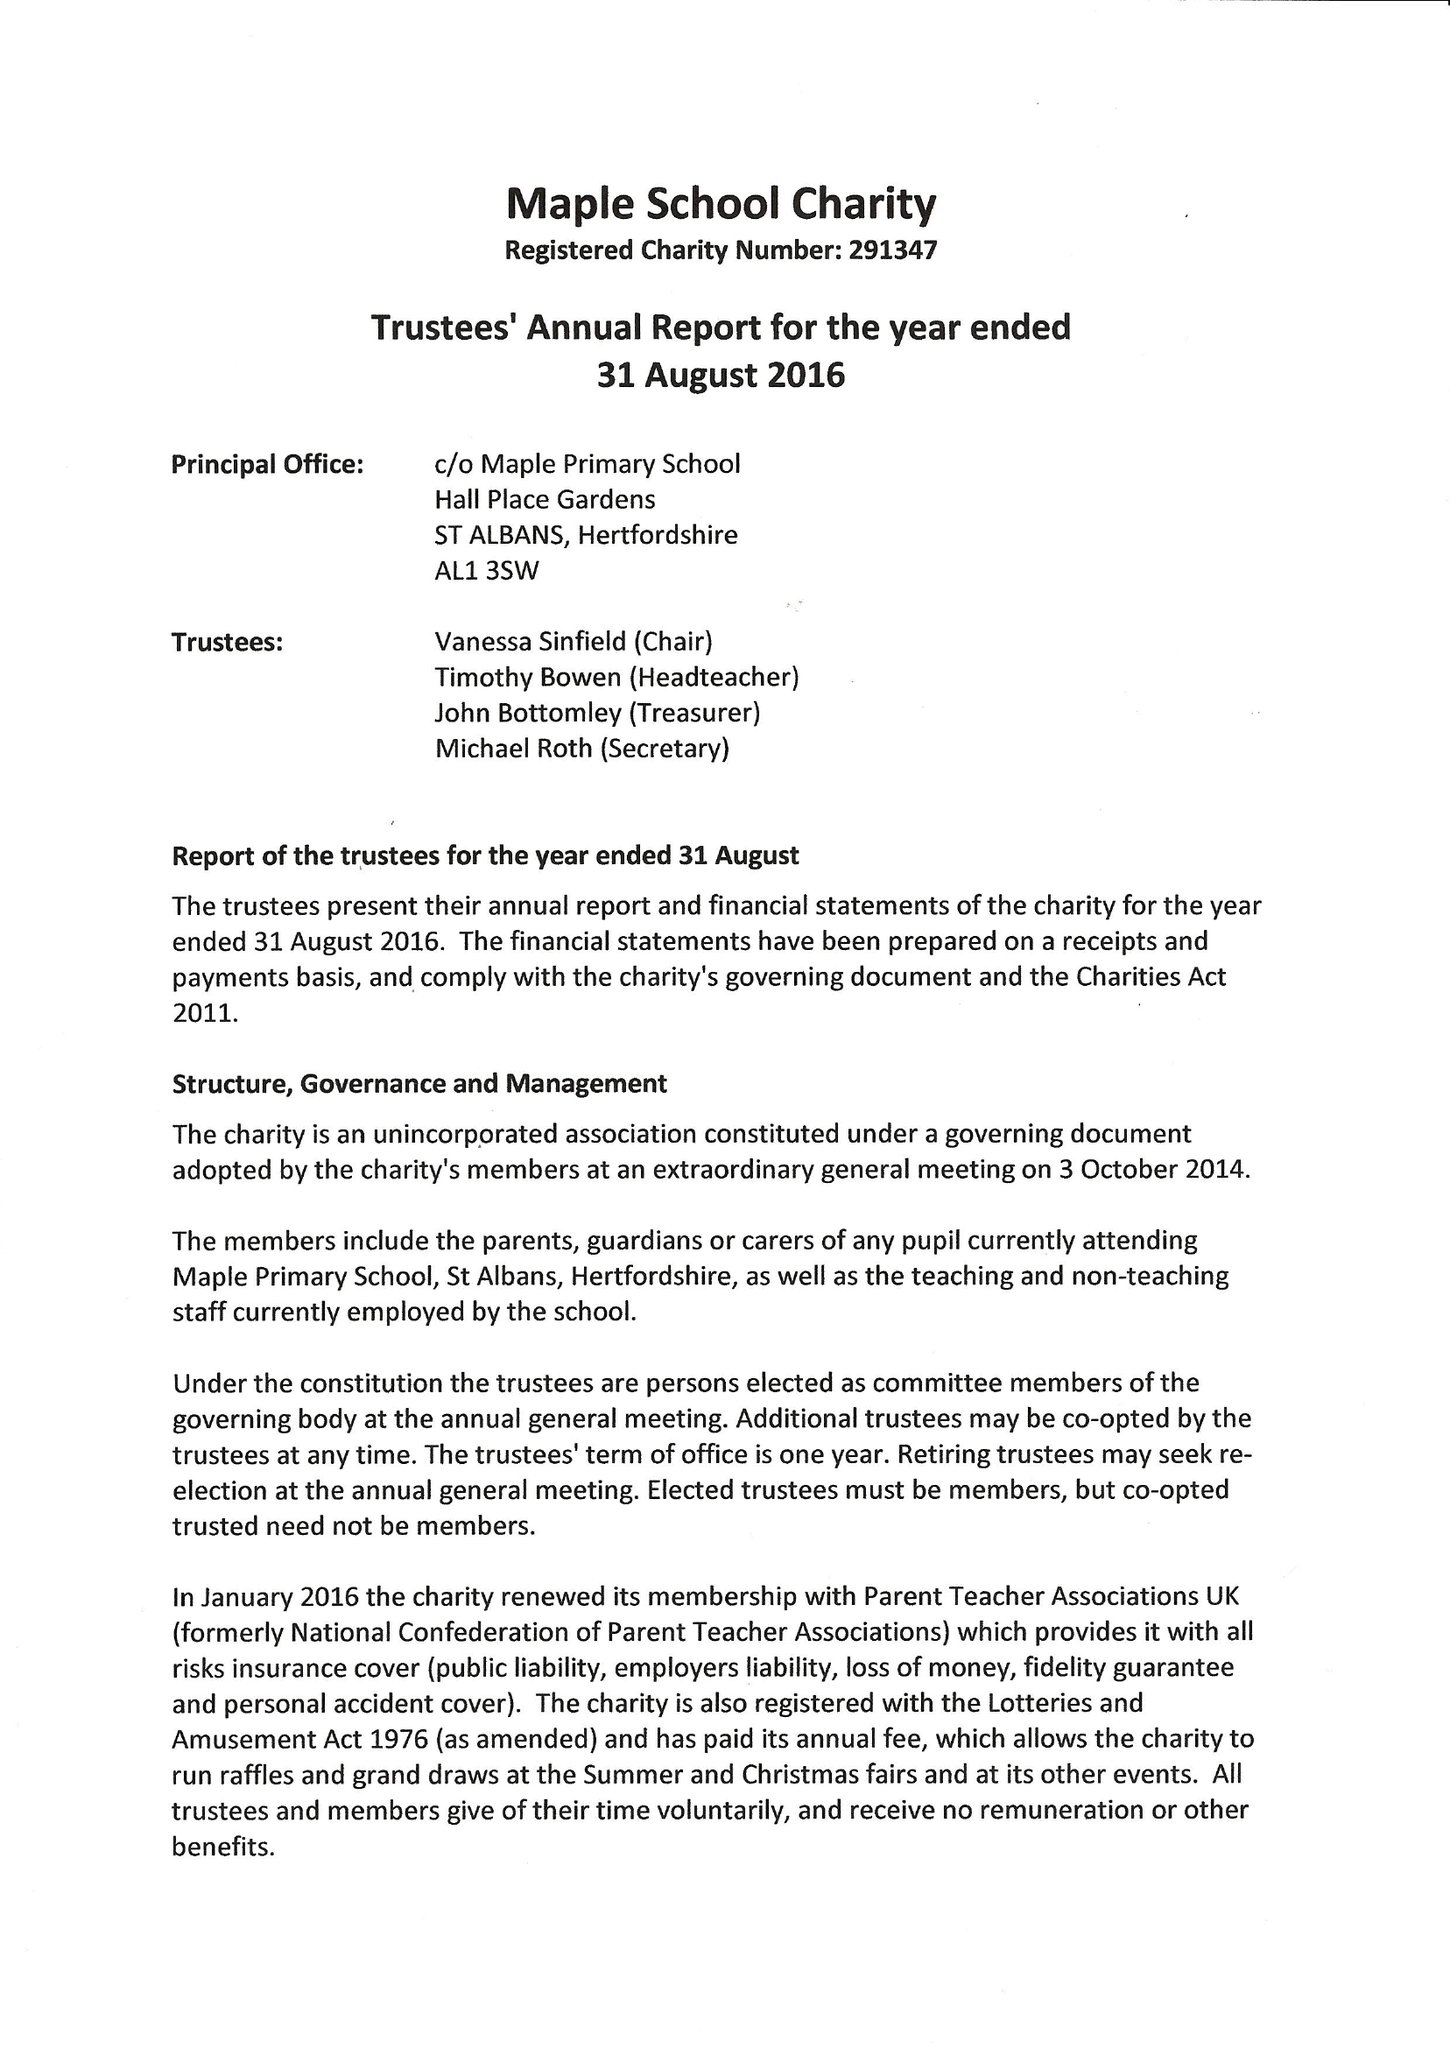What is the value for the charity_name?
Answer the question using a single word or phrase. Maple School Pta 